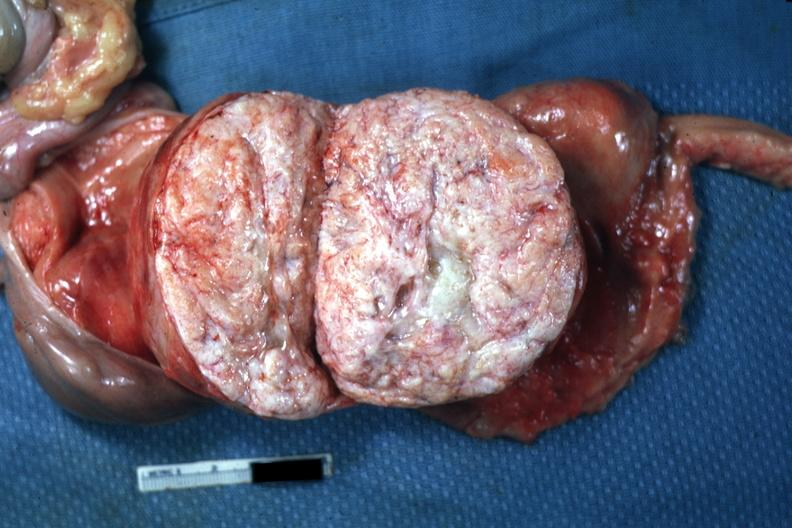where does this part belong to?
Answer the question using a single word or phrase. Female reproductive system 